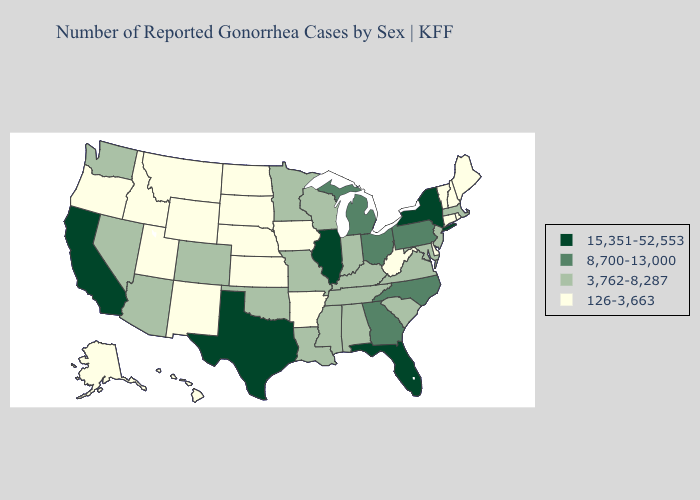Name the states that have a value in the range 15,351-52,553?
Concise answer only. California, Florida, Illinois, New York, Texas. What is the highest value in the USA?
Quick response, please. 15,351-52,553. Among the states that border Missouri , does Kentucky have the highest value?
Concise answer only. No. Among the states that border Iowa , does Minnesota have the lowest value?
Concise answer only. No. Does Washington have the lowest value in the USA?
Concise answer only. No. Which states hav the highest value in the South?
Short answer required. Florida, Texas. What is the value of Arizona?
Write a very short answer. 3,762-8,287. Does Massachusetts have the same value as Maryland?
Write a very short answer. Yes. What is the value of Arizona?
Short answer required. 3,762-8,287. Name the states that have a value in the range 3,762-8,287?
Be succinct. Alabama, Arizona, Colorado, Indiana, Kentucky, Louisiana, Maryland, Massachusetts, Minnesota, Mississippi, Missouri, Nevada, New Jersey, Oklahoma, South Carolina, Tennessee, Virginia, Washington, Wisconsin. What is the value of Texas?
Write a very short answer. 15,351-52,553. What is the value of Nevada?
Short answer required. 3,762-8,287. Does the first symbol in the legend represent the smallest category?
Quick response, please. No. Name the states that have a value in the range 126-3,663?
Quick response, please. Alaska, Arkansas, Connecticut, Delaware, Hawaii, Idaho, Iowa, Kansas, Maine, Montana, Nebraska, New Hampshire, New Mexico, North Dakota, Oregon, Rhode Island, South Dakota, Utah, Vermont, West Virginia, Wyoming. Name the states that have a value in the range 8,700-13,000?
Give a very brief answer. Georgia, Michigan, North Carolina, Ohio, Pennsylvania. 